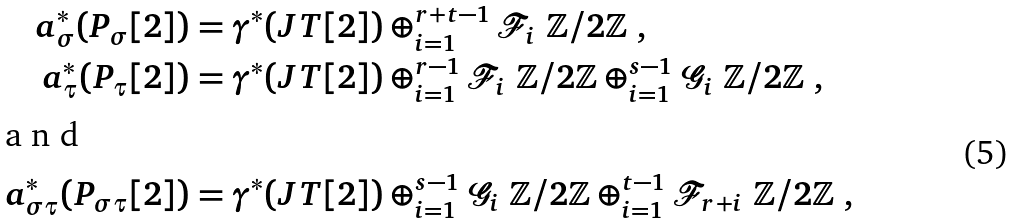<formula> <loc_0><loc_0><loc_500><loc_500>a _ { \sigma } ^ { * } ( P _ { \sigma } [ 2 ] ) & = \gamma ^ { * } ( J T [ 2 ] ) \oplus _ { i = 1 } ^ { r + t - 1 } { \mathcal { F } } _ { i } \ { \mathbb { Z } } / 2 { \mathbb { Z } } \ , \\ a _ { \tau } ^ { * } ( P _ { \tau } [ 2 ] ) & = \gamma ^ { * } ( J T [ 2 ] ) \oplus _ { i = 1 } ^ { r - 1 } { \mathcal { F } } _ { i } \ { \mathbb { Z } } / 2 { \mathbb { Z } } \oplus _ { i = 1 } ^ { s - 1 } { \mathcal { G } } _ { i } \ { \mathbb { Z } } / 2 { \mathbb { Z } } \ , \\ \intertext { a n d } a _ { \sigma \tau } ^ { * } ( P _ { \sigma \tau } [ 2 ] ) & = \gamma ^ { * } ( J T [ 2 ] ) \oplus _ { i = 1 } ^ { s - 1 } { \mathcal { G } } _ { i } \ { \mathbb { Z } } / 2 { \mathbb { Z } } \oplus _ { i = 1 } ^ { t - 1 } { \mathcal { F } } _ { r + i } \ { \mathbb { Z } } / 2 { \mathbb { Z } } \ ,</formula> 